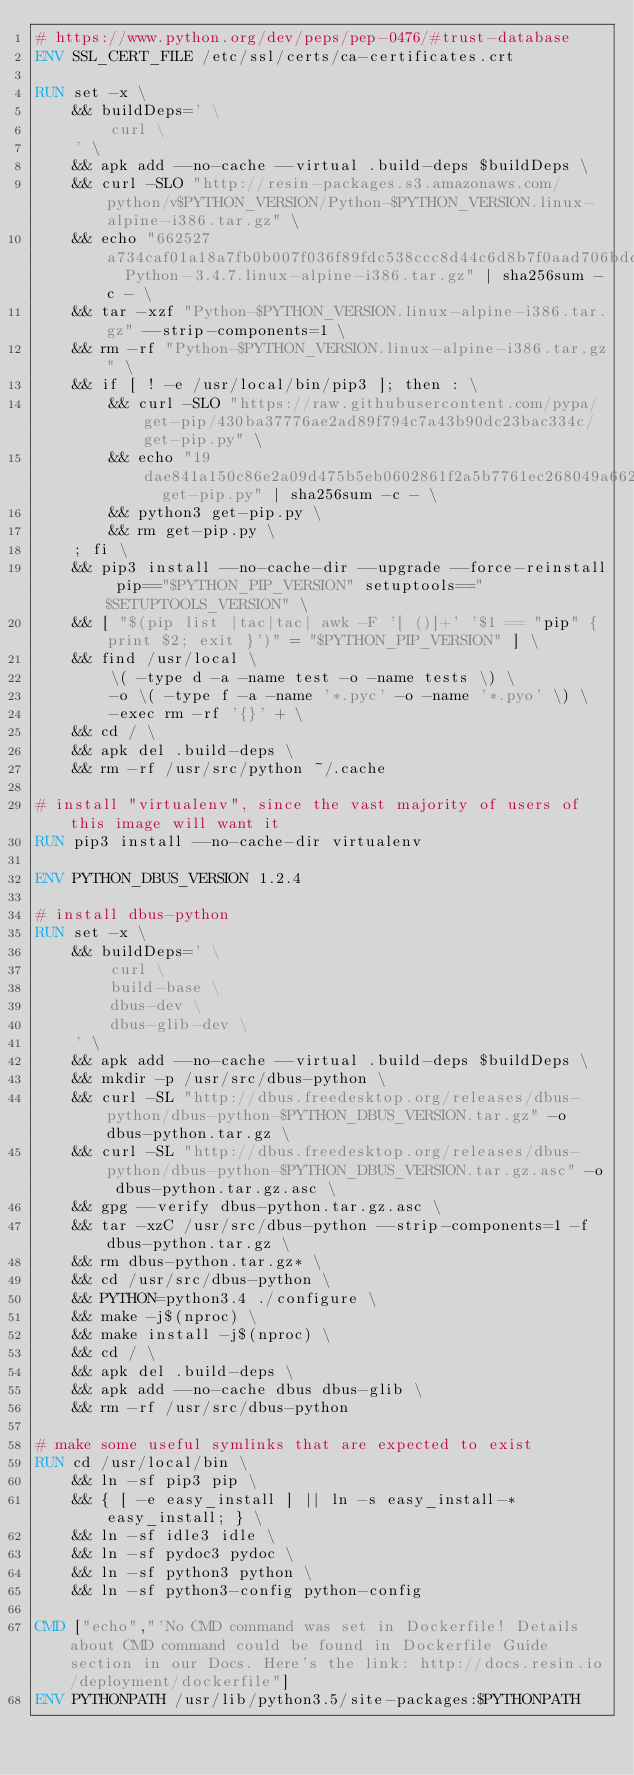Convert code to text. <code><loc_0><loc_0><loc_500><loc_500><_Dockerfile_># https://www.python.org/dev/peps/pep-0476/#trust-database
ENV SSL_CERT_FILE /etc/ssl/certs/ca-certificates.crt

RUN set -x \
	&& buildDeps=' \
		curl \
	' \
	&& apk add --no-cache --virtual .build-deps $buildDeps \
	&& curl -SLO "http://resin-packages.s3.amazonaws.com/python/v$PYTHON_VERSION/Python-$PYTHON_VERSION.linux-alpine-i386.tar.gz" \
	&& echo "662527a734caf01a18a7fb0b007f036f89fdc538ccc8d44c6d8b7f0aad706bdd  Python-3.4.7.linux-alpine-i386.tar.gz" | sha256sum -c - \
	&& tar -xzf "Python-$PYTHON_VERSION.linux-alpine-i386.tar.gz" --strip-components=1 \
	&& rm -rf "Python-$PYTHON_VERSION.linux-alpine-i386.tar.gz" \
	&& if [ ! -e /usr/local/bin/pip3 ]; then : \
		&& curl -SLO "https://raw.githubusercontent.com/pypa/get-pip/430ba37776ae2ad89f794c7a43b90dc23bac334c/get-pip.py" \
		&& echo "19dae841a150c86e2a09d475b5eb0602861f2a5b7761ec268049a662dbd2bd0c  get-pip.py" | sha256sum -c - \
		&& python3 get-pip.py \
		&& rm get-pip.py \
	; fi \
	&& pip3 install --no-cache-dir --upgrade --force-reinstall pip=="$PYTHON_PIP_VERSION" setuptools=="$SETUPTOOLS_VERSION" \
	&& [ "$(pip list |tac|tac| awk -F '[ ()]+' '$1 == "pip" { print $2; exit }')" = "$PYTHON_PIP_VERSION" ] \
	&& find /usr/local \
		\( -type d -a -name test -o -name tests \) \
		-o \( -type f -a -name '*.pyc' -o -name '*.pyo' \) \
		-exec rm -rf '{}' + \
	&& cd / \
	&& apk del .build-deps \
	&& rm -rf /usr/src/python ~/.cache

# install "virtualenv", since the vast majority of users of this image will want it
RUN pip3 install --no-cache-dir virtualenv

ENV PYTHON_DBUS_VERSION 1.2.4

# install dbus-python
RUN set -x \
	&& buildDeps=' \
		curl \
		build-base \
		dbus-dev \
		dbus-glib-dev \
	' \
	&& apk add --no-cache --virtual .build-deps $buildDeps \
	&& mkdir -p /usr/src/dbus-python \
	&& curl -SL "http://dbus.freedesktop.org/releases/dbus-python/dbus-python-$PYTHON_DBUS_VERSION.tar.gz" -o dbus-python.tar.gz \
	&& curl -SL "http://dbus.freedesktop.org/releases/dbus-python/dbus-python-$PYTHON_DBUS_VERSION.tar.gz.asc" -o dbus-python.tar.gz.asc \
	&& gpg --verify dbus-python.tar.gz.asc \
	&& tar -xzC /usr/src/dbus-python --strip-components=1 -f dbus-python.tar.gz \
	&& rm dbus-python.tar.gz* \
	&& cd /usr/src/dbus-python \
	&& PYTHON=python3.4 ./configure \
	&& make -j$(nproc) \
	&& make install -j$(nproc) \
	&& cd / \
	&& apk del .build-deps \
	&& apk add --no-cache dbus dbus-glib \
	&& rm -rf /usr/src/dbus-python

# make some useful symlinks that are expected to exist
RUN cd /usr/local/bin \
	&& ln -sf pip3 pip \
	&& { [ -e easy_install ] || ln -s easy_install-* easy_install; } \
	&& ln -sf idle3 idle \
	&& ln -sf pydoc3 pydoc \
	&& ln -sf python3 python \
	&& ln -sf python3-config python-config

CMD ["echo","'No CMD command was set in Dockerfile! Details about CMD command could be found in Dockerfile Guide section in our Docs. Here's the link: http://docs.resin.io/deployment/dockerfile"]
ENV PYTHONPATH /usr/lib/python3.5/site-packages:$PYTHONPATH
</code> 